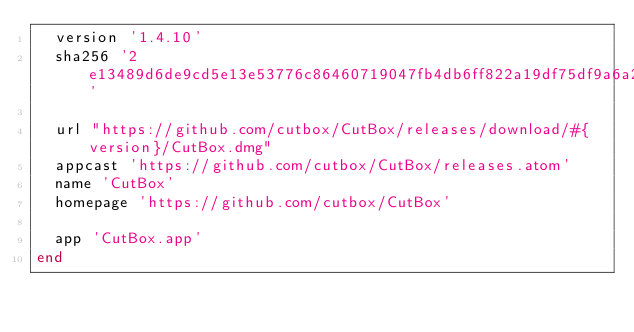<code> <loc_0><loc_0><loc_500><loc_500><_Ruby_>  version '1.4.10'
  sha256 '2e13489d6de9cd5e13e53776c86460719047fb4db6ff822a19df75df9a6a23e9'

  url "https://github.com/cutbox/CutBox/releases/download/#{version}/CutBox.dmg"
  appcast 'https://github.com/cutbox/CutBox/releases.atom'
  name 'CutBox'
  homepage 'https://github.com/cutbox/CutBox'

  app 'CutBox.app'
end
</code> 